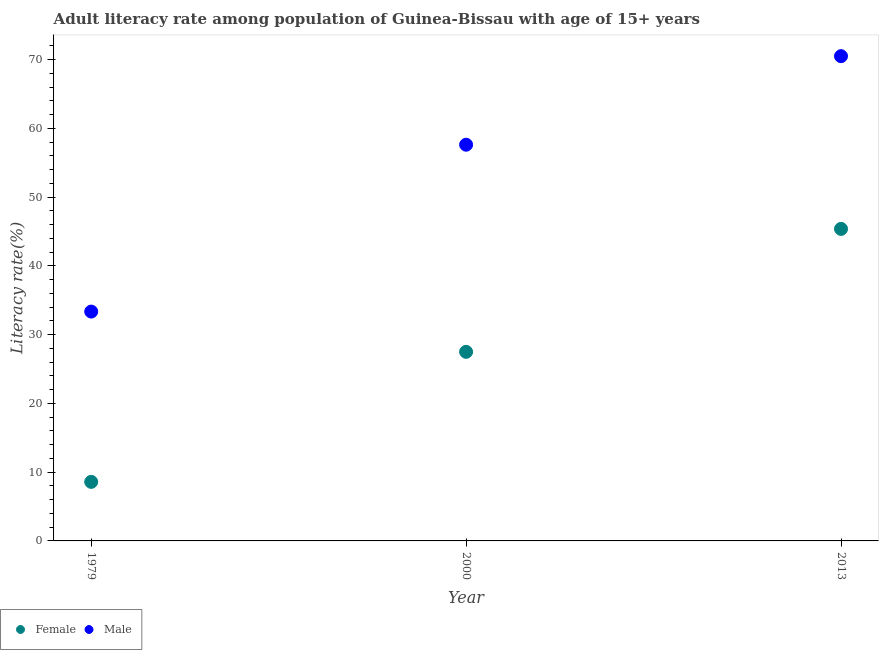Is the number of dotlines equal to the number of legend labels?
Make the answer very short. Yes. What is the female adult literacy rate in 2013?
Ensure brevity in your answer.  45.37. Across all years, what is the maximum male adult literacy rate?
Keep it short and to the point. 70.49. Across all years, what is the minimum female adult literacy rate?
Your answer should be very brief. 8.59. In which year was the male adult literacy rate minimum?
Make the answer very short. 1979. What is the total female adult literacy rate in the graph?
Give a very brief answer. 81.46. What is the difference between the male adult literacy rate in 2000 and that in 2013?
Provide a succinct answer. -12.88. What is the difference between the male adult literacy rate in 2013 and the female adult literacy rate in 2000?
Offer a terse response. 43. What is the average female adult literacy rate per year?
Your answer should be compact. 27.15. In the year 2013, what is the difference between the female adult literacy rate and male adult literacy rate?
Give a very brief answer. -25.12. In how many years, is the female adult literacy rate greater than 26 %?
Offer a terse response. 2. What is the ratio of the male adult literacy rate in 2000 to that in 2013?
Offer a terse response. 0.82. Is the female adult literacy rate in 1979 less than that in 2013?
Provide a short and direct response. Yes. What is the difference between the highest and the second highest male adult literacy rate?
Your response must be concise. 12.88. What is the difference between the highest and the lowest female adult literacy rate?
Give a very brief answer. 36.78. In how many years, is the female adult literacy rate greater than the average female adult literacy rate taken over all years?
Offer a very short reply. 2. Is the sum of the female adult literacy rate in 1979 and 2013 greater than the maximum male adult literacy rate across all years?
Offer a very short reply. No. Does the graph contain any zero values?
Your response must be concise. No. Where does the legend appear in the graph?
Your response must be concise. Bottom left. How are the legend labels stacked?
Offer a terse response. Horizontal. What is the title of the graph?
Offer a terse response. Adult literacy rate among population of Guinea-Bissau with age of 15+ years. Does "Arms exports" appear as one of the legend labels in the graph?
Provide a short and direct response. No. What is the label or title of the Y-axis?
Your answer should be compact. Literacy rate(%). What is the Literacy rate(%) of Female in 1979?
Your answer should be very brief. 8.59. What is the Literacy rate(%) in Male in 1979?
Provide a short and direct response. 33.35. What is the Literacy rate(%) of Female in 2000?
Ensure brevity in your answer.  27.49. What is the Literacy rate(%) of Male in 2000?
Your answer should be compact. 57.61. What is the Literacy rate(%) of Female in 2013?
Give a very brief answer. 45.37. What is the Literacy rate(%) of Male in 2013?
Make the answer very short. 70.49. Across all years, what is the maximum Literacy rate(%) of Female?
Your answer should be compact. 45.37. Across all years, what is the maximum Literacy rate(%) of Male?
Keep it short and to the point. 70.49. Across all years, what is the minimum Literacy rate(%) in Female?
Give a very brief answer. 8.59. Across all years, what is the minimum Literacy rate(%) in Male?
Provide a succinct answer. 33.35. What is the total Literacy rate(%) of Female in the graph?
Your answer should be compact. 81.46. What is the total Literacy rate(%) in Male in the graph?
Ensure brevity in your answer.  161.45. What is the difference between the Literacy rate(%) in Female in 1979 and that in 2000?
Offer a very short reply. -18.91. What is the difference between the Literacy rate(%) in Male in 1979 and that in 2000?
Provide a succinct answer. -24.26. What is the difference between the Literacy rate(%) in Female in 1979 and that in 2013?
Provide a short and direct response. -36.78. What is the difference between the Literacy rate(%) in Male in 1979 and that in 2013?
Keep it short and to the point. -37.14. What is the difference between the Literacy rate(%) of Female in 2000 and that in 2013?
Make the answer very short. -17.88. What is the difference between the Literacy rate(%) in Male in 2000 and that in 2013?
Your response must be concise. -12.88. What is the difference between the Literacy rate(%) in Female in 1979 and the Literacy rate(%) in Male in 2000?
Provide a succinct answer. -49.03. What is the difference between the Literacy rate(%) in Female in 1979 and the Literacy rate(%) in Male in 2013?
Provide a succinct answer. -61.9. What is the difference between the Literacy rate(%) in Female in 2000 and the Literacy rate(%) in Male in 2013?
Keep it short and to the point. -43. What is the average Literacy rate(%) of Female per year?
Keep it short and to the point. 27.15. What is the average Literacy rate(%) in Male per year?
Provide a short and direct response. 53.82. In the year 1979, what is the difference between the Literacy rate(%) in Female and Literacy rate(%) in Male?
Offer a terse response. -24.76. In the year 2000, what is the difference between the Literacy rate(%) in Female and Literacy rate(%) in Male?
Your response must be concise. -30.12. In the year 2013, what is the difference between the Literacy rate(%) in Female and Literacy rate(%) in Male?
Your response must be concise. -25.12. What is the ratio of the Literacy rate(%) of Female in 1979 to that in 2000?
Your answer should be compact. 0.31. What is the ratio of the Literacy rate(%) in Male in 1979 to that in 2000?
Your response must be concise. 0.58. What is the ratio of the Literacy rate(%) of Female in 1979 to that in 2013?
Provide a succinct answer. 0.19. What is the ratio of the Literacy rate(%) of Male in 1979 to that in 2013?
Provide a succinct answer. 0.47. What is the ratio of the Literacy rate(%) in Female in 2000 to that in 2013?
Offer a very short reply. 0.61. What is the ratio of the Literacy rate(%) of Male in 2000 to that in 2013?
Keep it short and to the point. 0.82. What is the difference between the highest and the second highest Literacy rate(%) in Female?
Give a very brief answer. 17.88. What is the difference between the highest and the second highest Literacy rate(%) in Male?
Make the answer very short. 12.88. What is the difference between the highest and the lowest Literacy rate(%) of Female?
Make the answer very short. 36.78. What is the difference between the highest and the lowest Literacy rate(%) in Male?
Offer a very short reply. 37.14. 